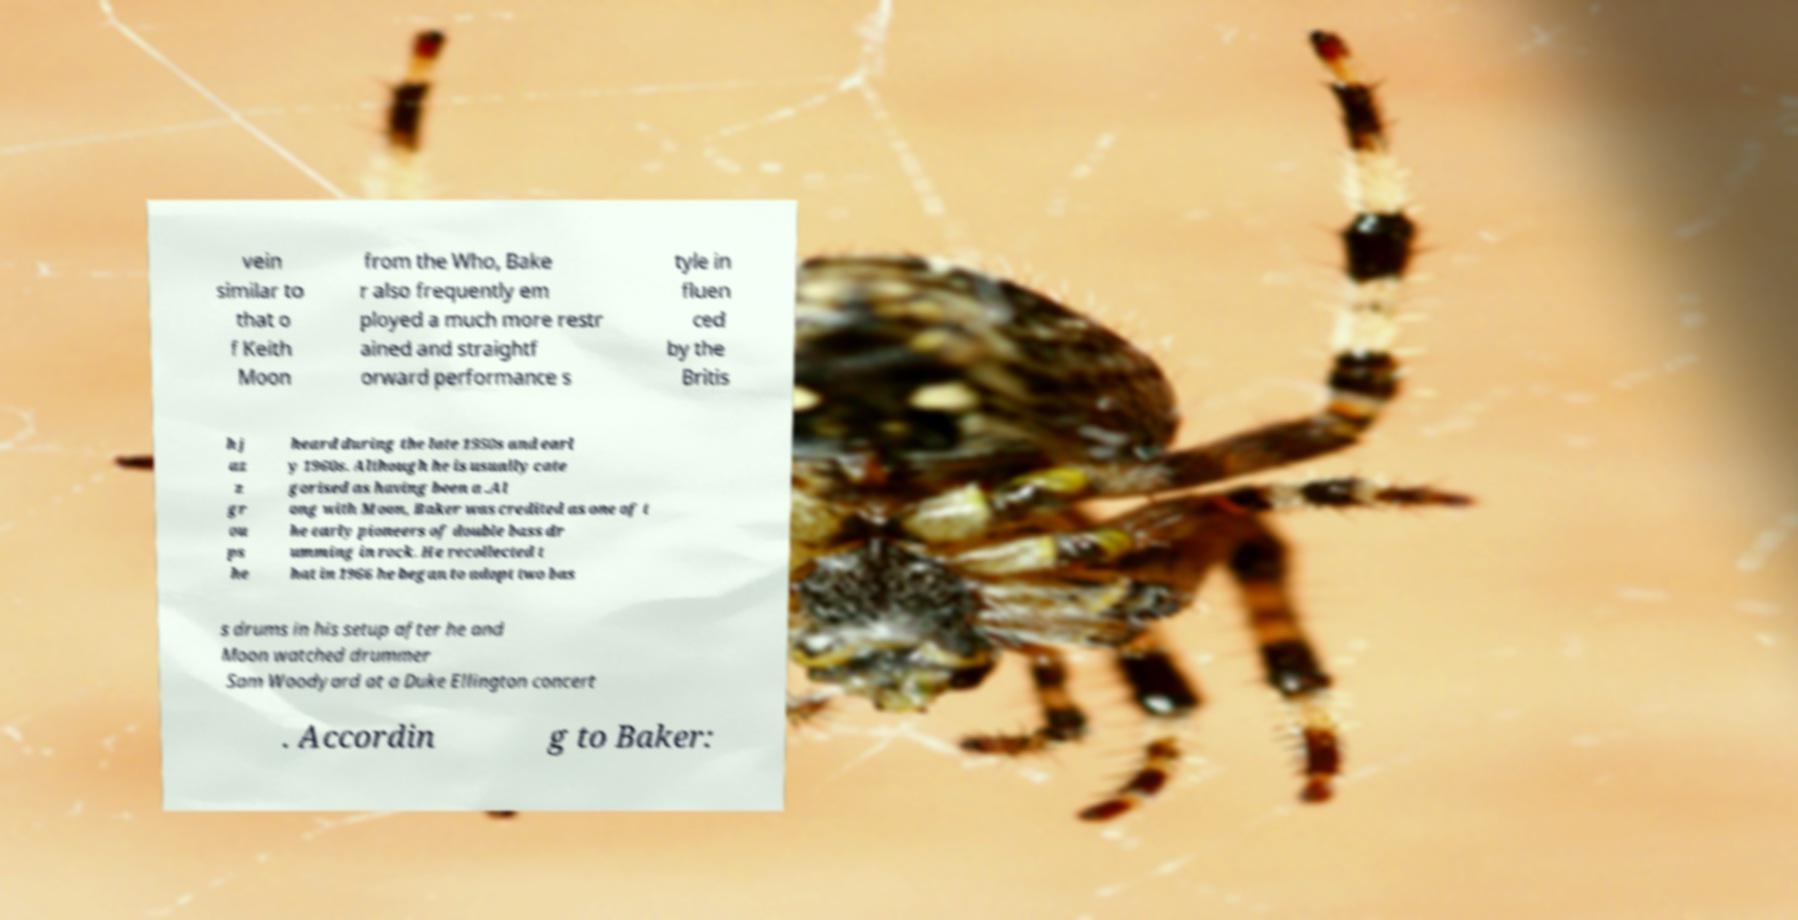What messages or text are displayed in this image? I need them in a readable, typed format. vein similar to that o f Keith Moon from the Who, Bake r also frequently em ployed a much more restr ained and straightf orward performance s tyle in fluen ced by the Britis h j az z gr ou ps he heard during the late 1950s and earl y 1960s. Although he is usually cate gorised as having been a .Al ong with Moon, Baker was credited as one of t he early pioneers of double bass dr umming in rock. He recollected t hat in 1966 he began to adopt two bas s drums in his setup after he and Moon watched drummer Sam Woodyard at a Duke Ellington concert . Accordin g to Baker: 